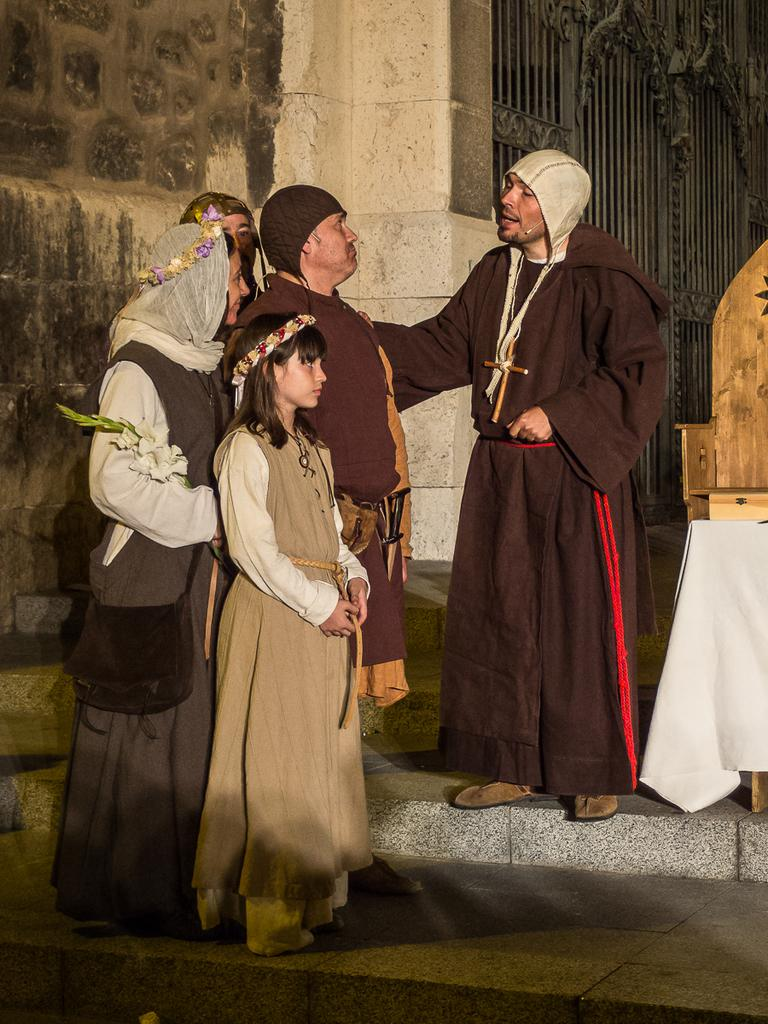What is the main subject of the image? The main subject of the image is a group of people standing in the center. What can be seen on the left side of the image? There is a wall on the left side of the image. What is visible in the background of the image? There is a gate visible in the background of the image. What is the surface on which the people are standing? There is a floor at the bottom of the image. What type of cable can be seen hanging from the wall in the image? There is no cable hanging from the wall in the image. Is there any dirt visible on the floor in the image? The provided facts do not mention any dirt on the floor, so we cannot determine its presence from the image. 